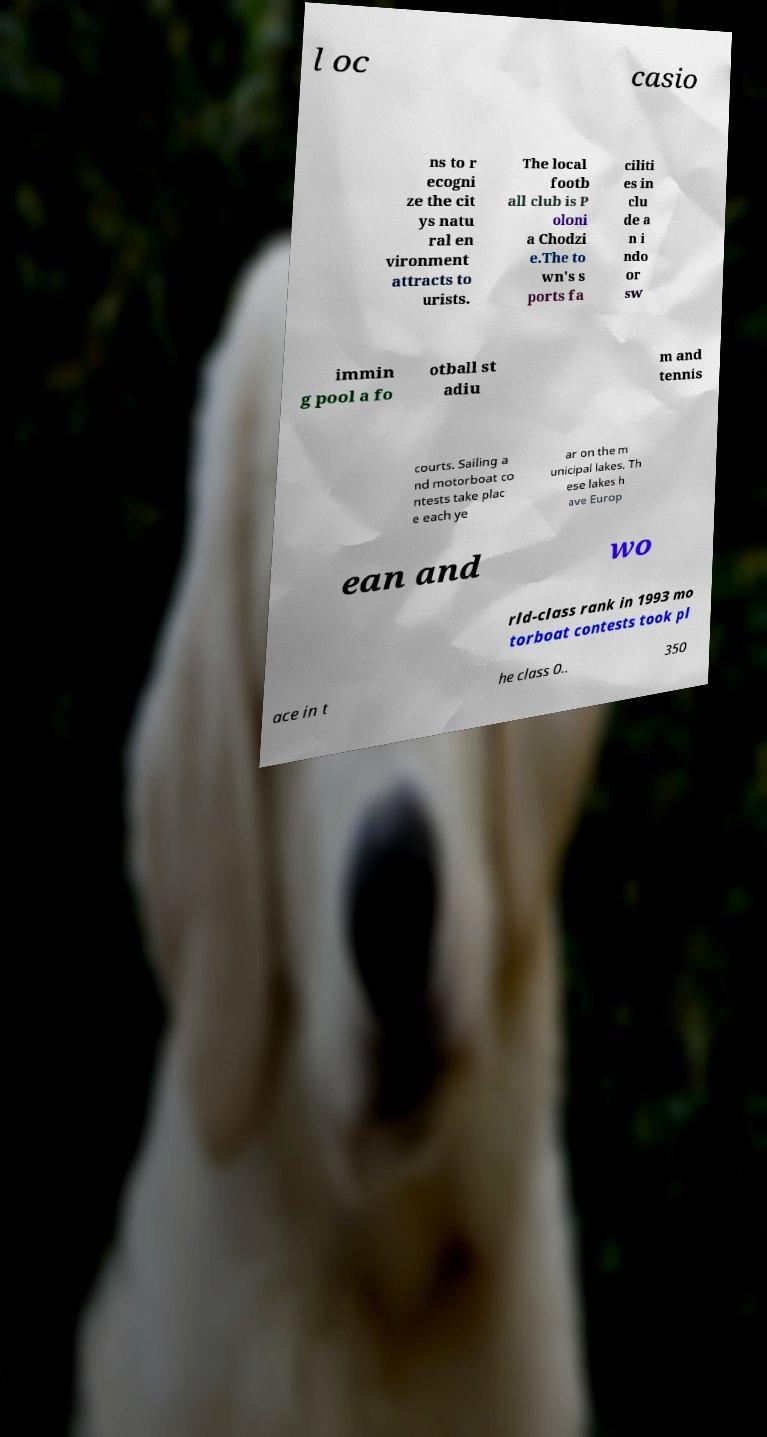For documentation purposes, I need the text within this image transcribed. Could you provide that? l oc casio ns to r ecogni ze the cit ys natu ral en vironment attracts to urists. The local footb all club is P oloni a Chodzi e.The to wn's s ports fa ciliti es in clu de a n i ndo or sw immin g pool a fo otball st adiu m and tennis courts. Sailing a nd motorboat co ntests take plac e each ye ar on the m unicipal lakes. Th ese lakes h ave Europ ean and wo rld-class rank in 1993 mo torboat contests took pl ace in t he class 0.. 350 